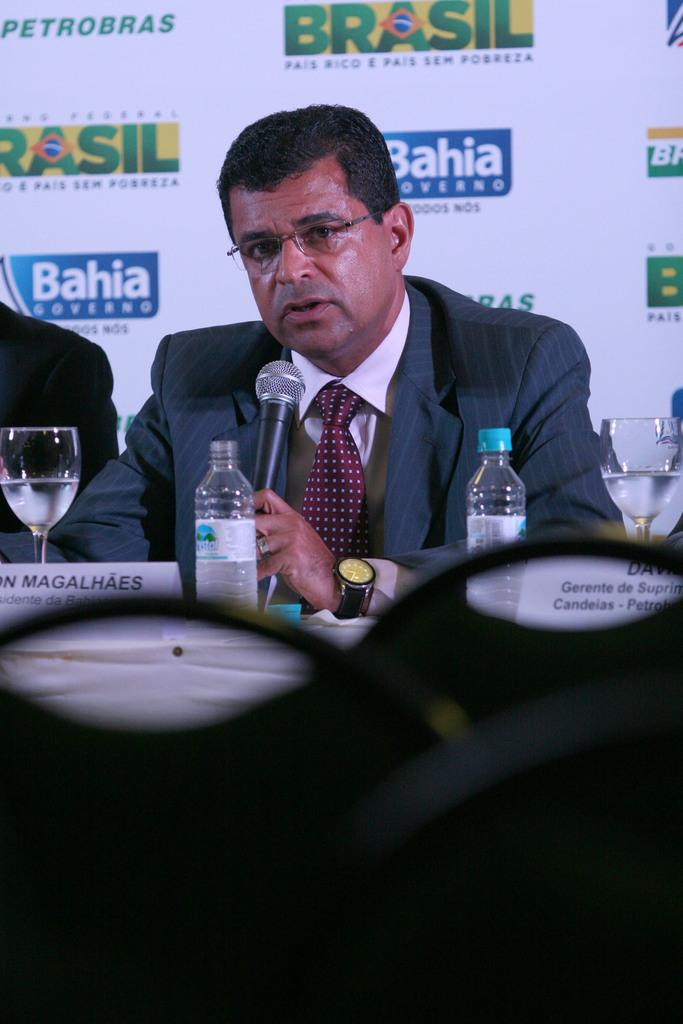Who is the main subject in the image? There is a man in the image. What is the man holding in the image? The man is holding a microphone. What is the man doing in the image? The man is speaking. What other objects can be seen in the image? There is a bottle and a glass in the image. What is visible in the background of the image? There is a hoarding in the background of the image. What type of fruit is the man holding in the image? There is no fruit present in the image; the man is holding a microphone. Is there a yard visible in the image? There is no yard visible in the image; the background features a hoarding. 